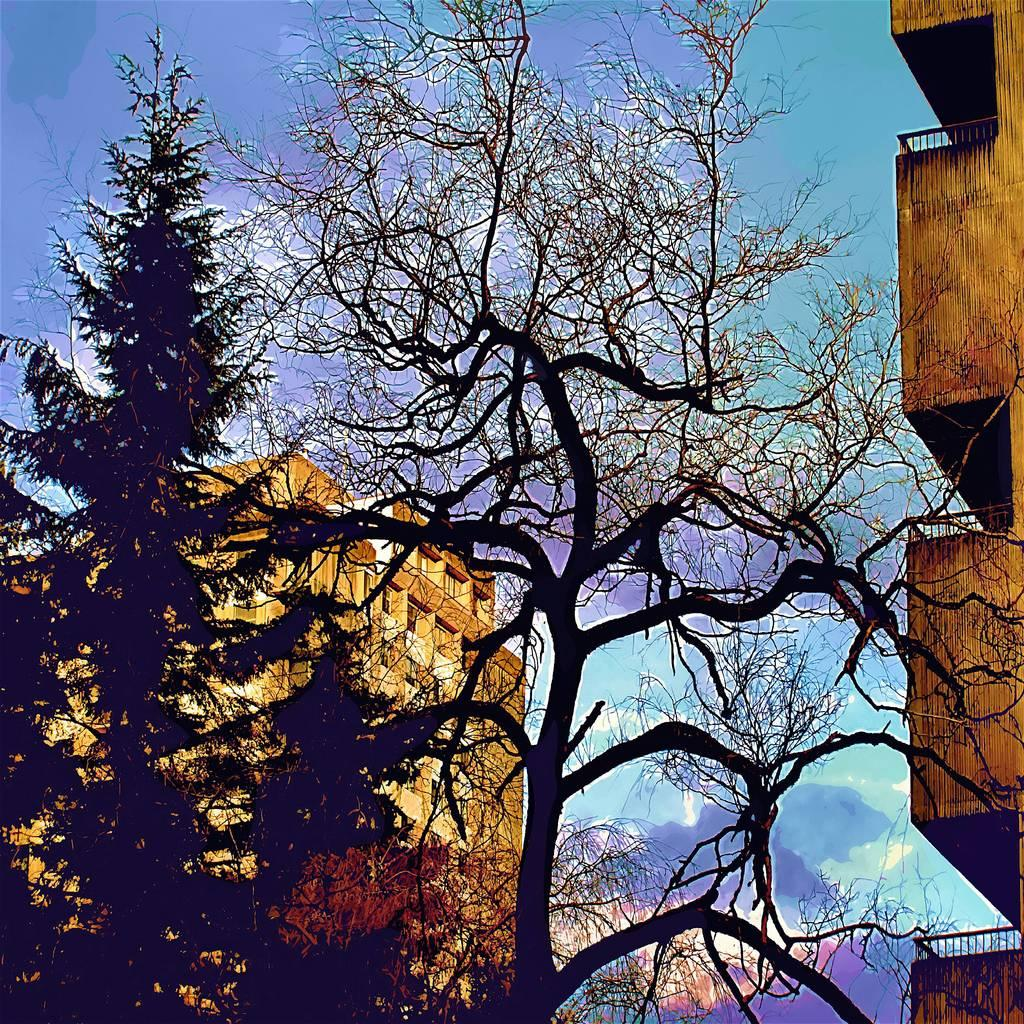What structures are located on both sides of the image? There are buildings on either side of the image. What type of vegetation can be seen in the image? There are trees visible in the image. What color is the sky in the background of the image? The sky is blue in the background of the image. How long does it take for the grandfather to bake cookies in the oven in the image? There is no grandfather or oven present in the image, so it is not possible to answer that question. 